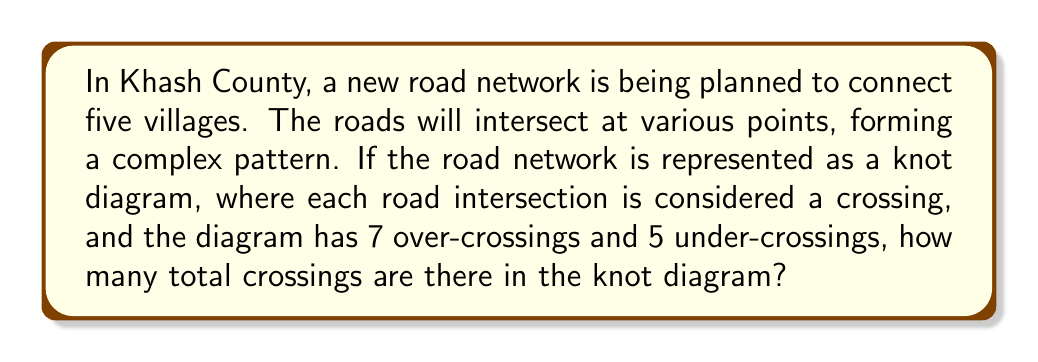Provide a solution to this math problem. To solve this problem, we need to understand the following concepts:

1. In knot theory, a crossing in a knot diagram represents an intersection point where one strand passes over or under another strand.

2. The total number of crossings in a knot diagram is the sum of all over-crossings and under-crossings.

Let's proceed step-by-step:

1. Identify the given information:
   - Number of over-crossings: 7
   - Number of under-crossings: 5

2. Calculate the total number of crossings:
   $$\text{Total crossings} = \text{Over-crossings} + \text{Under-crossings}$$
   $$\text{Total crossings} = 7 + 5 = 12$$

Therefore, the knot diagram representing the road network in Khash County has a total of 12 crossings.
Answer: 12 crossings 